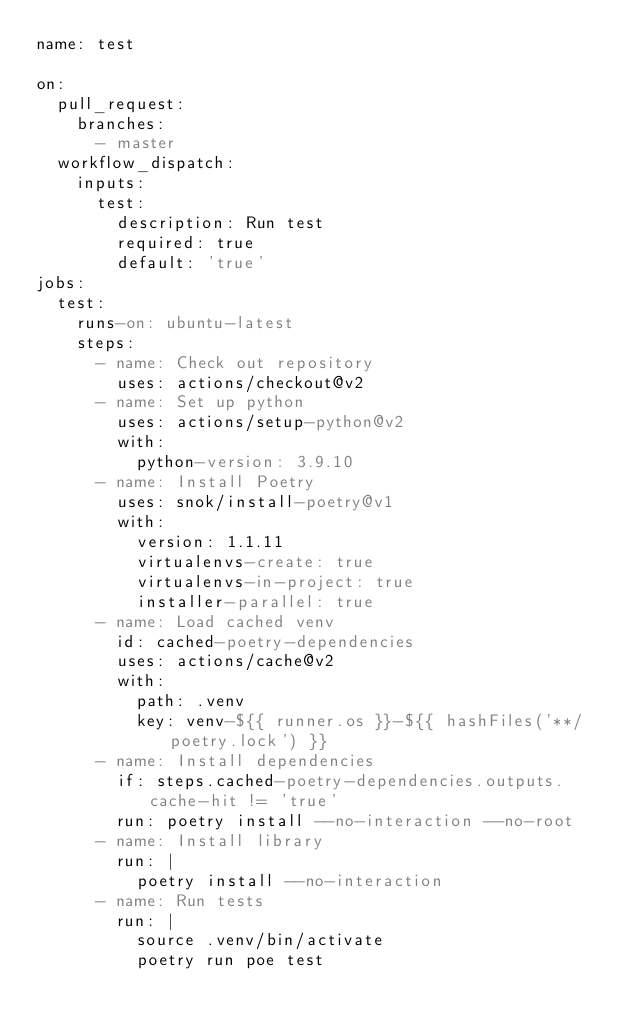<code> <loc_0><loc_0><loc_500><loc_500><_YAML_>name: test

on:
  pull_request:
    branches:
      - master
  workflow_dispatch:
    inputs:
      test:
        description: Run test
        required: true
        default: 'true'
jobs:
  test:
    runs-on: ubuntu-latest
    steps:
      - name: Check out repository
        uses: actions/checkout@v2
      - name: Set up python
        uses: actions/setup-python@v2
        with:
          python-version: 3.9.10
      - name: Install Poetry
        uses: snok/install-poetry@v1
        with:
          version: 1.1.11
          virtualenvs-create: true
          virtualenvs-in-project: true
          installer-parallel: true
      - name: Load cached venv
        id: cached-poetry-dependencies
        uses: actions/cache@v2
        with:
          path: .venv
          key: venv-${{ runner.os }}-${{ hashFiles('**/poetry.lock') }}
      - name: Install dependencies
        if: steps.cached-poetry-dependencies.outputs.cache-hit != 'true'
        run: poetry install --no-interaction --no-root
      - name: Install library
        run: |
          poetry install --no-interaction
      - name: Run tests
        run: |
          source .venv/bin/activate
          poetry run poe test
</code> 